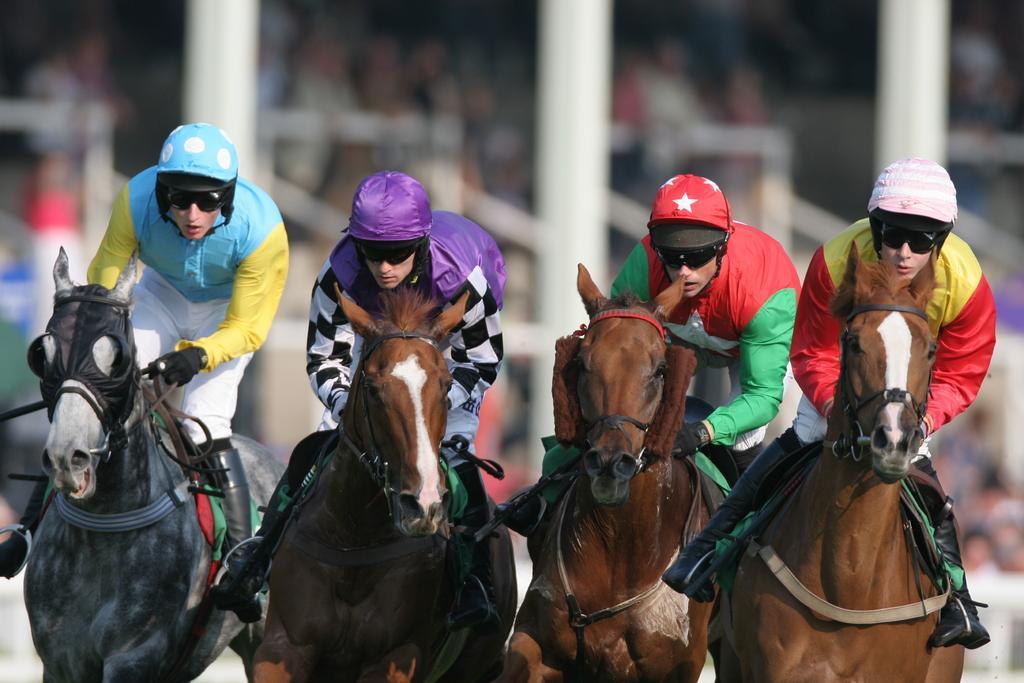Could you give a brief overview of what you see in this image? In the picture we can see four horses with four people are sitting on it and riding it and they are in sports wear and helmets and behind them we can see audience are watching them and they are not clearly visible. 